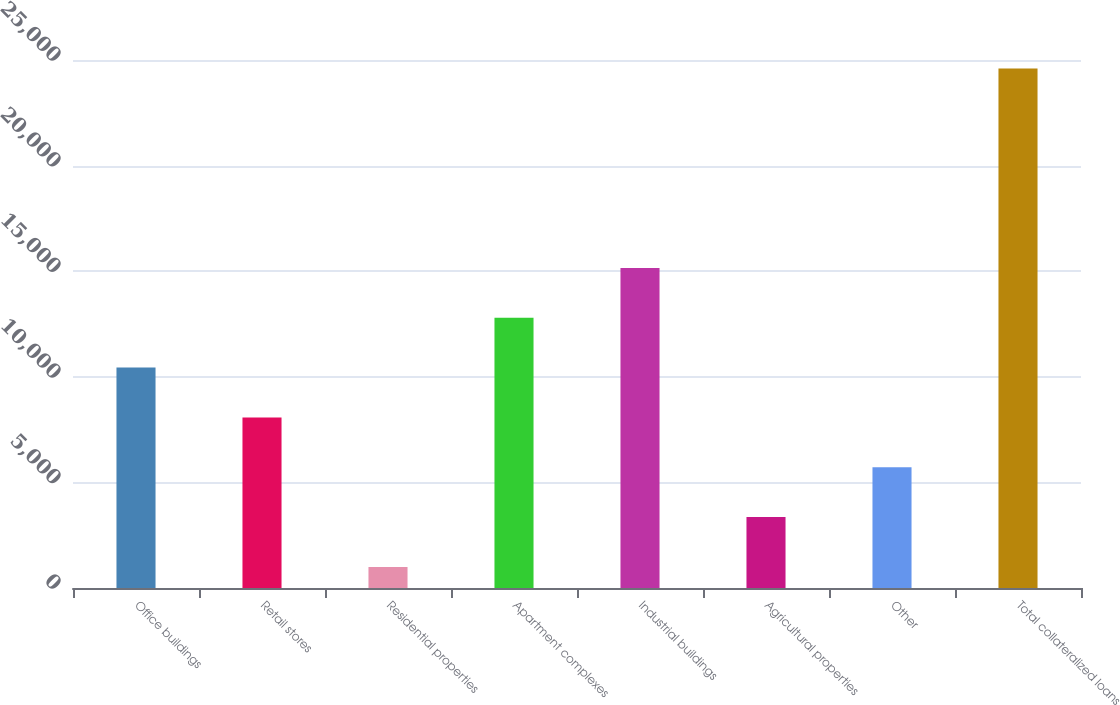Convert chart to OTSL. <chart><loc_0><loc_0><loc_500><loc_500><bar_chart><fcel>Office buildings<fcel>Retail stores<fcel>Residential properties<fcel>Apartment complexes<fcel>Industrial buildings<fcel>Agricultural properties<fcel>Other<fcel>Total collateralized loans<nl><fcel>10437<fcel>8077.5<fcel>999<fcel>12796.5<fcel>15156<fcel>3358.5<fcel>5718<fcel>24594<nl></chart> 